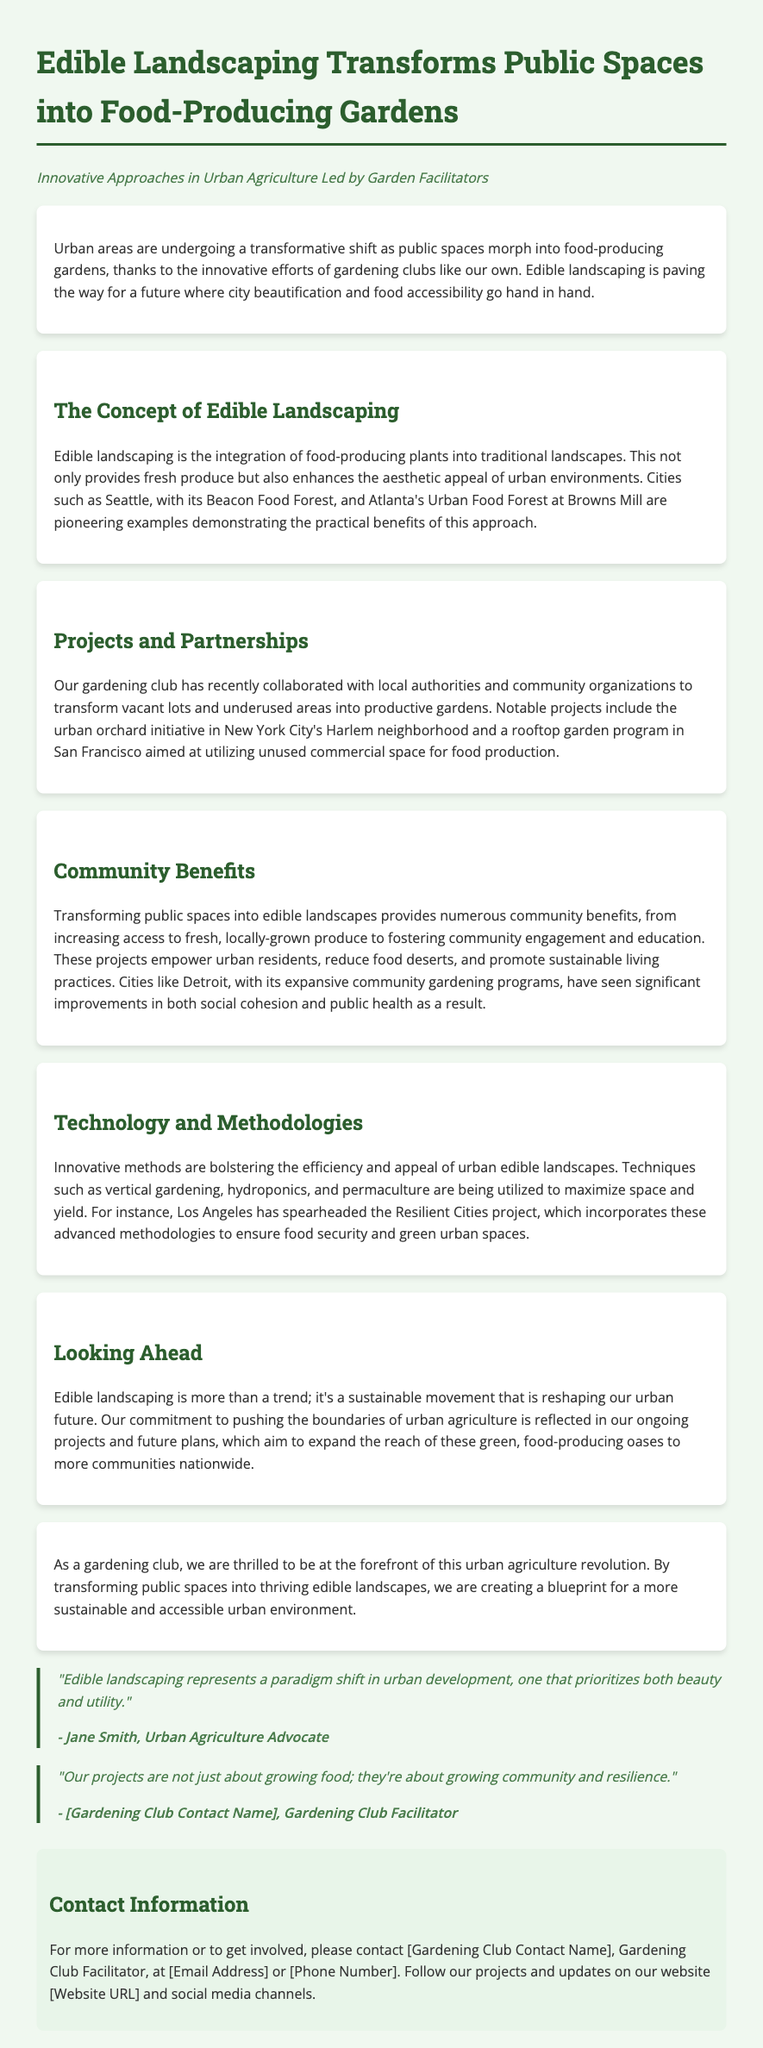What is the title of the press release? The title of the press release is stated at the beginning and is "Edible Landscaping Transforms Public Spaces into Food-Producing Gardens."
Answer: Edible Landscaping Transforms Public Spaces into Food-Producing Gardens What is a notable project mentioned in the document? The document lists several projects, one of which is the urban orchard initiative in New York City's Harlem neighborhood.
Answer: urban orchard initiative in New York City's Harlem neighborhood What city has a pioneering edible landscape project called Beacon Food Forest? The document mentions Seattle as having the Beacon Food Forest.
Answer: Seattle What methodology is highlighted for maximizing space in urban gardens? Techniques such as vertical gardening, hydroponics, and permaculture are mentioned in relation to maximizing space.
Answer: vertical gardening, hydroponics, and permaculture Who is quoted as an Urban Agriculture Advocate in the press release? The document includes a quote from Jane Smith as an Urban Agriculture Advocate.
Answer: Jane Smith What is the primary goal of transforming public spaces into edible landscapes? The primary goal is to enhance food accessibility and community engagement while beautifying urban spaces.
Answer: enhance food accessibility and community engagement How does the gardening club view its role in urban agriculture? The gardening club sees itself as being at the forefront of the urban agriculture revolution.
Answer: at the forefront of the urban agriculture revolution What aspect of community is emphasized in the quote about projects growing community and resilience? The quote emphasizes the importance of community and resilience as integral outcomes of gardening projects.
Answer: community and resilience 